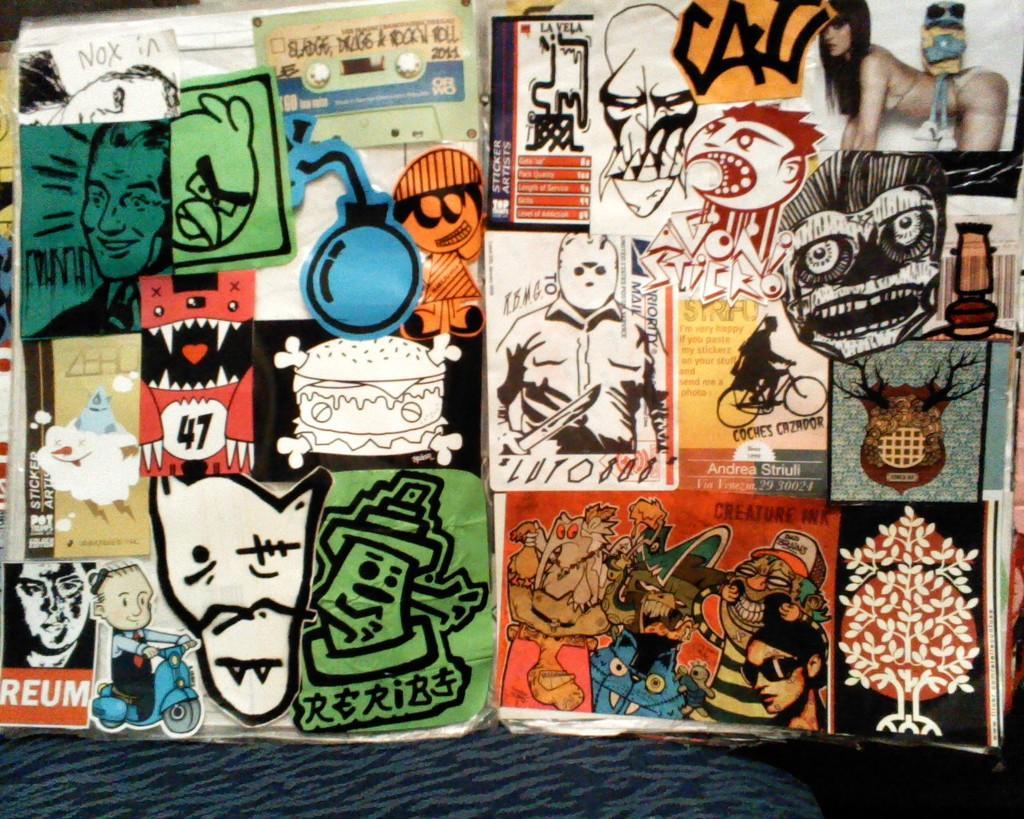Could you give a brief overview of what you see in this image? In this image, I think these are the posters. I can see the pictures of the persons, tree, cartoon images into posters. At the bottom of the image, I think this is a cloth with a design on it. 